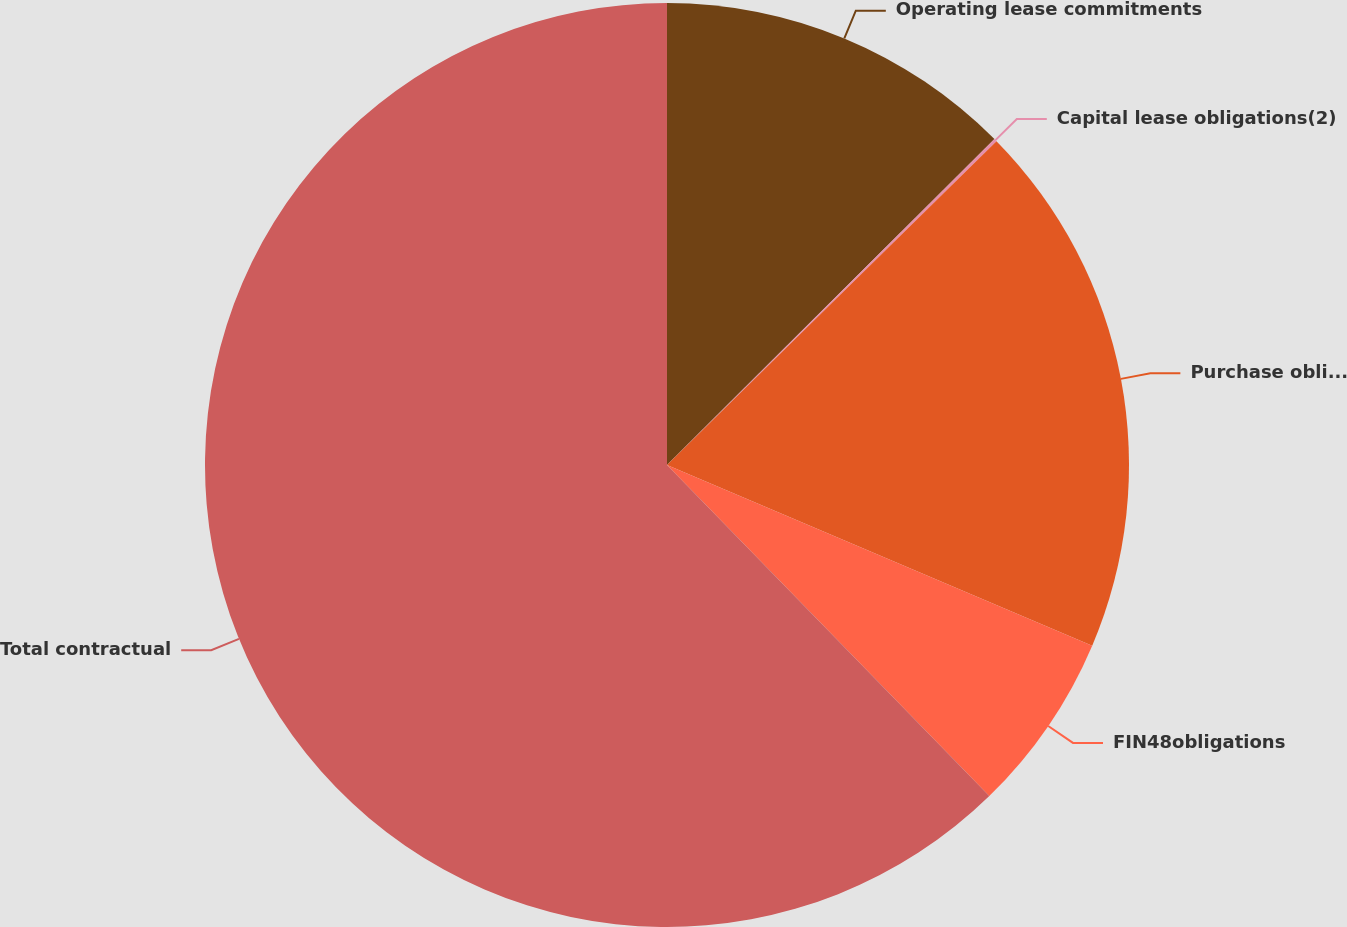Convert chart. <chart><loc_0><loc_0><loc_500><loc_500><pie_chart><fcel>Operating lease commitments<fcel>Capital lease obligations(2)<fcel>Purchase obligations(3)<fcel>FIN48obligations<fcel>Total contractual<nl><fcel>12.54%<fcel>0.1%<fcel>18.76%<fcel>6.32%<fcel>62.3%<nl></chart> 